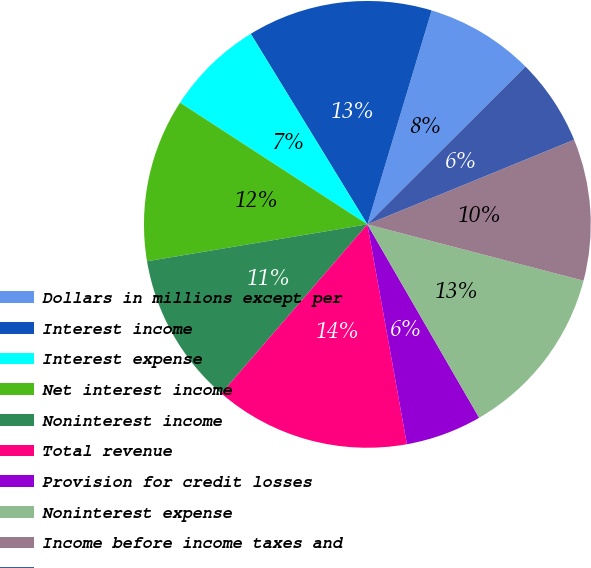<chart> <loc_0><loc_0><loc_500><loc_500><pie_chart><fcel>Dollars in millions except per<fcel>Interest income<fcel>Interest expense<fcel>Net interest income<fcel>Noninterest income<fcel>Total revenue<fcel>Provision for credit losses<fcel>Noninterest expense<fcel>Income before income taxes and<fcel>Income taxes<nl><fcel>7.87%<fcel>13.39%<fcel>7.09%<fcel>11.81%<fcel>11.02%<fcel>14.17%<fcel>5.51%<fcel>12.6%<fcel>10.24%<fcel>6.3%<nl></chart> 